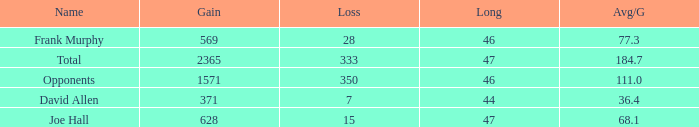How much Avg/G has a Gain smaller than 1571, and a Long smaller than 46? 1.0. 